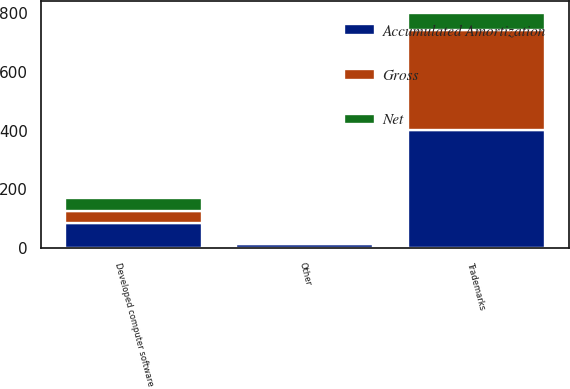Convert chart to OTSL. <chart><loc_0><loc_0><loc_500><loc_500><stacked_bar_chart><ecel><fcel>Developed computer software<fcel>Trademarks<fcel>Other<nl><fcel>Accumulated Amortization<fcel>84.9<fcel>400.9<fcel>12.4<nl><fcel>Net<fcel>44.9<fcel>59.8<fcel>7.5<nl><fcel>Gross<fcel>40<fcel>341.1<fcel>4.9<nl></chart> 